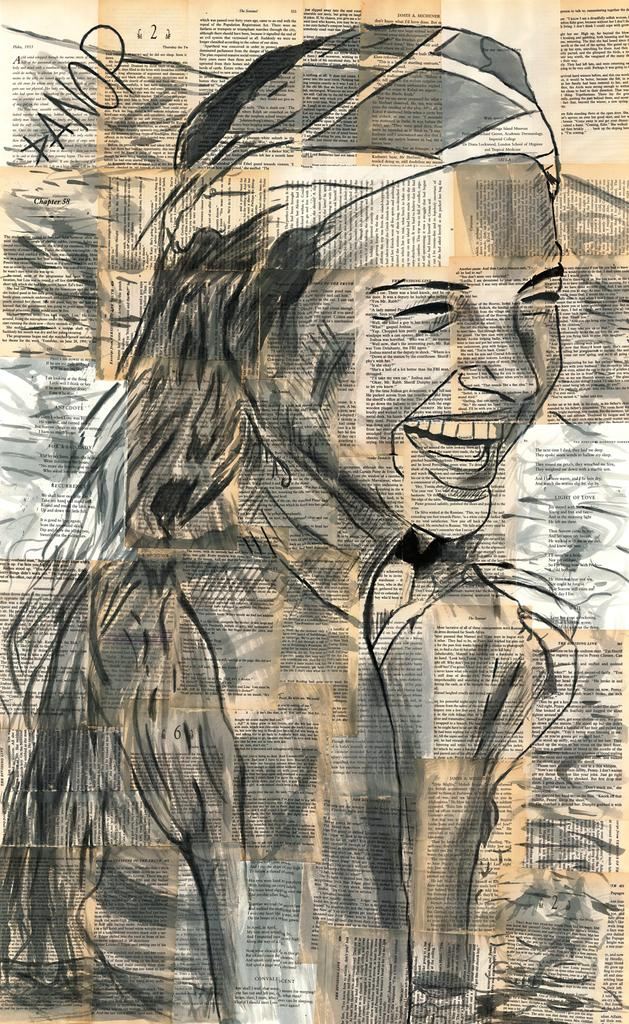What is the main subject in the center of the image? There is a poster in the center of the image. What is depicted on the poster? The poster contains a drawing of a woman smiling. Are there any words on the poster? Yes, there is text on the poster. Who is the owner of the boys in the image? There are no boys present in the image, so it is not possible to determine the owner of any boys. 